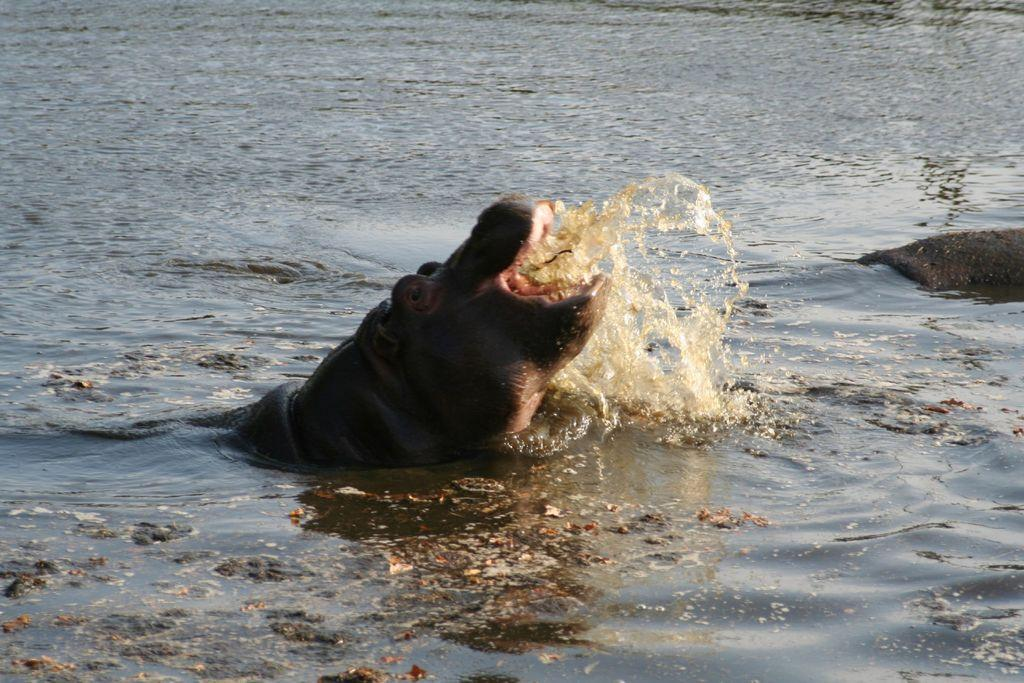What is visible in the image? Water is visible in the image. What animals can be seen in the water? There are two hippopotamuses in the water. What type of oil can be seen floating on the water in the image? There is no oil present in the image; it only features water and hippopotamuses. 